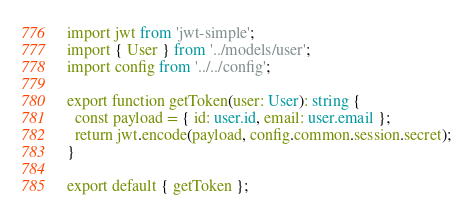Convert code to text. <code><loc_0><loc_0><loc_500><loc_500><_TypeScript_>import jwt from 'jwt-simple';
import { User } from '../models/user';
import config from '../../config';

export function getToken(user: User): string {
  const payload = { id: user.id, email: user.email };
  return jwt.encode(payload, config.common.session.secret);
}

export default { getToken };
</code> 